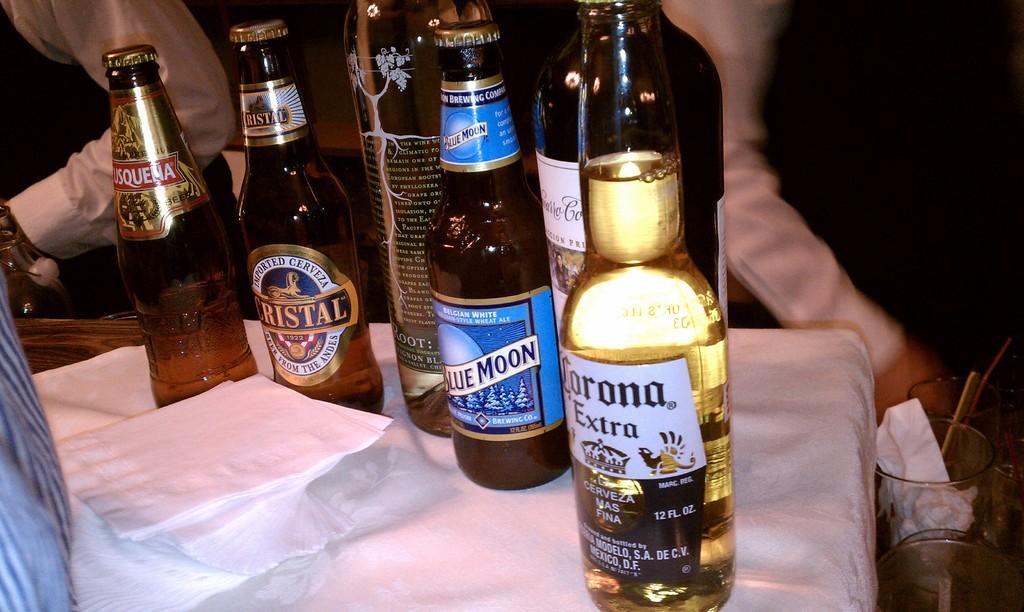What brand of beer on the left?
Make the answer very short. Cristal. 